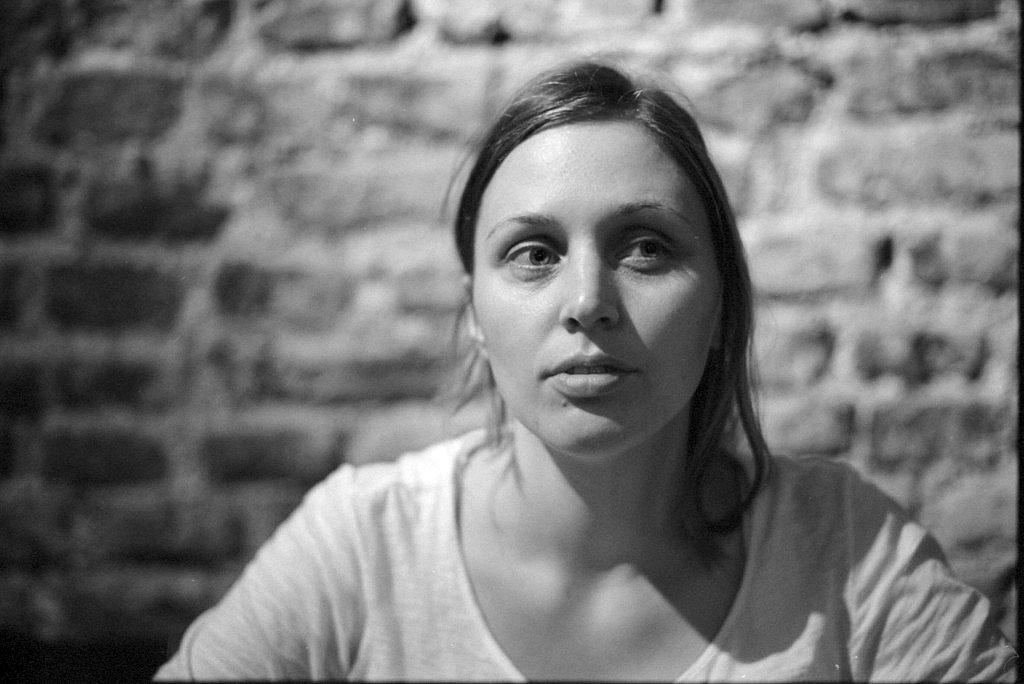Who is the main subject in the foreground of the image? There is a woman in the foreground of the image. What can be seen in the background of the image? There is a wall in the background of the image. Can you describe the lighting conditions in the image? The image may have been taken during the night, as there is no indication of daylight. What type of owl can be seen perched on the bed in the image? There is no owl or bed present in the image; it features a woman and a wall. 